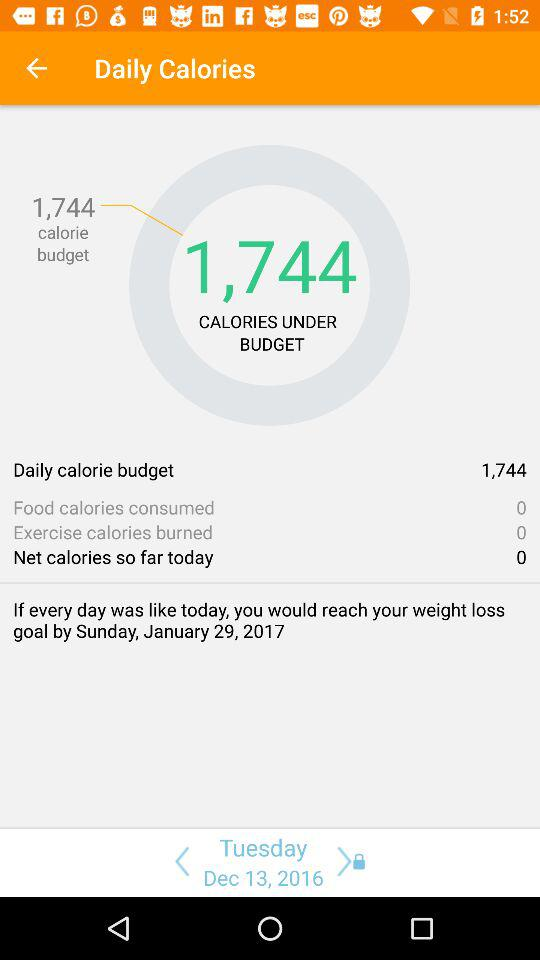How many calories have you burned through exercise?
Answer the question using a single word or phrase. 0 